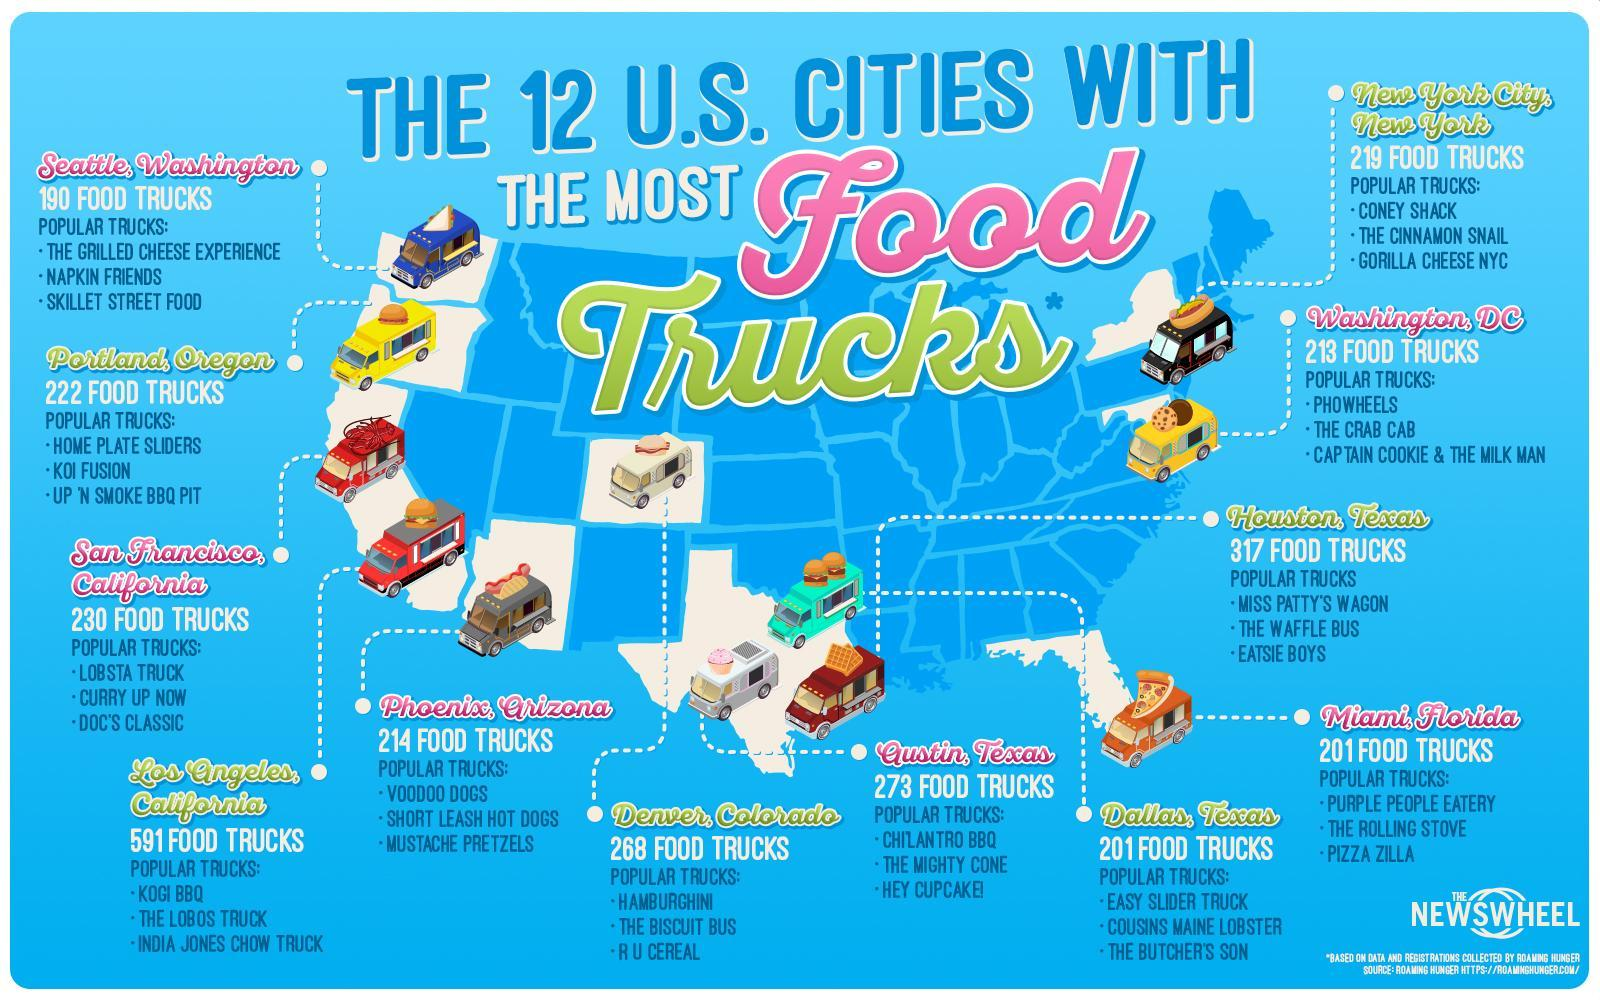Which city in the U.S. has the most number of food trucks?
Answer the question with a short phrase. Houston, Texas How many states in the U.S. have a lower number of food trucks? 41 states What is the total number of food trucks present in the three cities of Texas? 791 How many states have the highest number of food trucks in the U.S.? 9 states Which are the two cities that have the most food trucks in California? San Francisco, Los Angeles Which city in the U.S. has the lowest number of food trucks? 190 